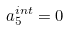<formula> <loc_0><loc_0><loc_500><loc_500>a _ { 5 } ^ { i n t } = 0</formula> 